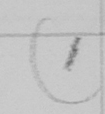What text is written in this handwritten line? ( 1 